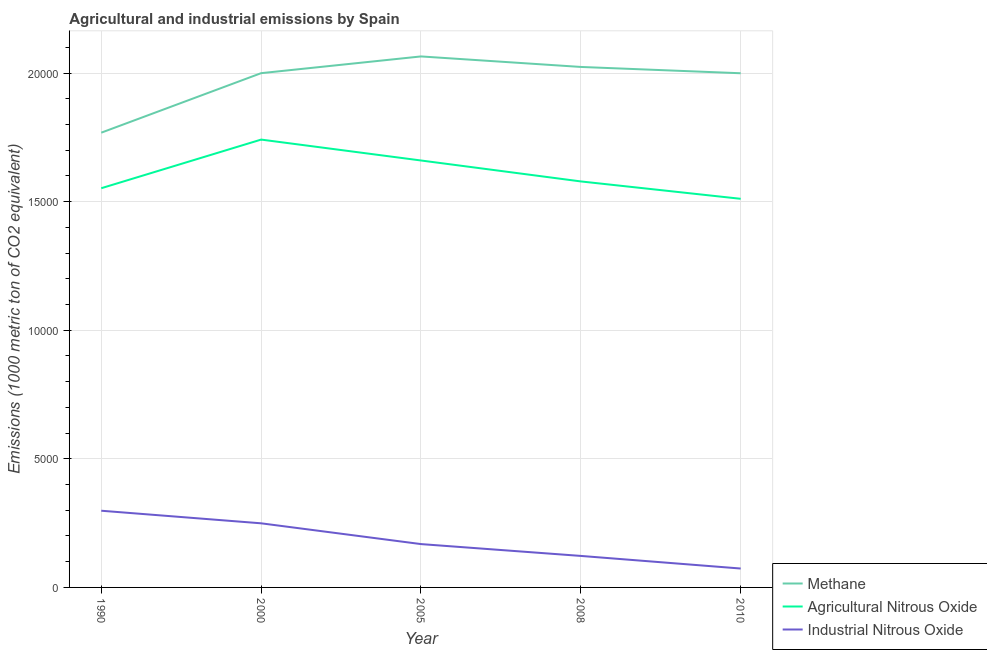How many different coloured lines are there?
Offer a terse response. 3. Is the number of lines equal to the number of legend labels?
Provide a short and direct response. Yes. What is the amount of industrial nitrous oxide emissions in 2010?
Ensure brevity in your answer.  734.8. Across all years, what is the maximum amount of agricultural nitrous oxide emissions?
Provide a short and direct response. 1.74e+04. Across all years, what is the minimum amount of agricultural nitrous oxide emissions?
Your answer should be very brief. 1.51e+04. In which year was the amount of methane emissions maximum?
Make the answer very short. 2005. In which year was the amount of agricultural nitrous oxide emissions minimum?
Provide a short and direct response. 2010. What is the total amount of industrial nitrous oxide emissions in the graph?
Ensure brevity in your answer.  9120.2. What is the difference between the amount of methane emissions in 1990 and that in 2010?
Provide a succinct answer. -2311. What is the difference between the amount of industrial nitrous oxide emissions in 2010 and the amount of methane emissions in 2005?
Keep it short and to the point. -1.99e+04. What is the average amount of methane emissions per year?
Your answer should be very brief. 1.97e+04. In the year 2008, what is the difference between the amount of industrial nitrous oxide emissions and amount of agricultural nitrous oxide emissions?
Offer a very short reply. -1.46e+04. What is the ratio of the amount of industrial nitrous oxide emissions in 1990 to that in 2010?
Offer a terse response. 4.06. Is the amount of industrial nitrous oxide emissions in 1990 less than that in 2005?
Your answer should be very brief. No. Is the difference between the amount of industrial nitrous oxide emissions in 1990 and 2010 greater than the difference between the amount of agricultural nitrous oxide emissions in 1990 and 2010?
Ensure brevity in your answer.  Yes. What is the difference between the highest and the second highest amount of methane emissions?
Offer a terse response. 408.9. What is the difference between the highest and the lowest amount of methane emissions?
Offer a very short reply. 2964.8. In how many years, is the amount of industrial nitrous oxide emissions greater than the average amount of industrial nitrous oxide emissions taken over all years?
Keep it short and to the point. 2. Is the sum of the amount of industrial nitrous oxide emissions in 2005 and 2008 greater than the maximum amount of agricultural nitrous oxide emissions across all years?
Provide a succinct answer. No. Does the amount of methane emissions monotonically increase over the years?
Keep it short and to the point. No. Is the amount of agricultural nitrous oxide emissions strictly greater than the amount of industrial nitrous oxide emissions over the years?
Keep it short and to the point. Yes. Is the amount of methane emissions strictly less than the amount of agricultural nitrous oxide emissions over the years?
Your answer should be compact. No. How many years are there in the graph?
Offer a very short reply. 5. Are the values on the major ticks of Y-axis written in scientific E-notation?
Give a very brief answer. No. Does the graph contain grids?
Provide a short and direct response. Yes. Where does the legend appear in the graph?
Ensure brevity in your answer.  Bottom right. How many legend labels are there?
Ensure brevity in your answer.  3. How are the legend labels stacked?
Your answer should be compact. Vertical. What is the title of the graph?
Keep it short and to the point. Agricultural and industrial emissions by Spain. What is the label or title of the Y-axis?
Your answer should be very brief. Emissions (1000 metric ton of CO2 equivalent). What is the Emissions (1000 metric ton of CO2 equivalent) of Methane in 1990?
Provide a short and direct response. 1.77e+04. What is the Emissions (1000 metric ton of CO2 equivalent) of Agricultural Nitrous Oxide in 1990?
Your answer should be compact. 1.55e+04. What is the Emissions (1000 metric ton of CO2 equivalent) in Industrial Nitrous Oxide in 1990?
Make the answer very short. 2982.4. What is the Emissions (1000 metric ton of CO2 equivalent) of Methane in 2000?
Give a very brief answer. 2.00e+04. What is the Emissions (1000 metric ton of CO2 equivalent) of Agricultural Nitrous Oxide in 2000?
Your answer should be compact. 1.74e+04. What is the Emissions (1000 metric ton of CO2 equivalent) of Industrial Nitrous Oxide in 2000?
Provide a short and direct response. 2493. What is the Emissions (1000 metric ton of CO2 equivalent) of Methane in 2005?
Give a very brief answer. 2.06e+04. What is the Emissions (1000 metric ton of CO2 equivalent) of Agricultural Nitrous Oxide in 2005?
Ensure brevity in your answer.  1.66e+04. What is the Emissions (1000 metric ton of CO2 equivalent) of Industrial Nitrous Oxide in 2005?
Your response must be concise. 1685.1. What is the Emissions (1000 metric ton of CO2 equivalent) of Methane in 2008?
Your response must be concise. 2.02e+04. What is the Emissions (1000 metric ton of CO2 equivalent) in Agricultural Nitrous Oxide in 2008?
Offer a terse response. 1.58e+04. What is the Emissions (1000 metric ton of CO2 equivalent) in Industrial Nitrous Oxide in 2008?
Your response must be concise. 1224.9. What is the Emissions (1000 metric ton of CO2 equivalent) in Methane in 2010?
Offer a terse response. 2.00e+04. What is the Emissions (1000 metric ton of CO2 equivalent) in Agricultural Nitrous Oxide in 2010?
Offer a terse response. 1.51e+04. What is the Emissions (1000 metric ton of CO2 equivalent) in Industrial Nitrous Oxide in 2010?
Your response must be concise. 734.8. Across all years, what is the maximum Emissions (1000 metric ton of CO2 equivalent) in Methane?
Provide a succinct answer. 2.06e+04. Across all years, what is the maximum Emissions (1000 metric ton of CO2 equivalent) of Agricultural Nitrous Oxide?
Offer a very short reply. 1.74e+04. Across all years, what is the maximum Emissions (1000 metric ton of CO2 equivalent) of Industrial Nitrous Oxide?
Your answer should be compact. 2982.4. Across all years, what is the minimum Emissions (1000 metric ton of CO2 equivalent) in Methane?
Offer a terse response. 1.77e+04. Across all years, what is the minimum Emissions (1000 metric ton of CO2 equivalent) in Agricultural Nitrous Oxide?
Give a very brief answer. 1.51e+04. Across all years, what is the minimum Emissions (1000 metric ton of CO2 equivalent) of Industrial Nitrous Oxide?
Your response must be concise. 734.8. What is the total Emissions (1000 metric ton of CO2 equivalent) of Methane in the graph?
Your answer should be compact. 9.86e+04. What is the total Emissions (1000 metric ton of CO2 equivalent) of Agricultural Nitrous Oxide in the graph?
Keep it short and to the point. 8.04e+04. What is the total Emissions (1000 metric ton of CO2 equivalent) in Industrial Nitrous Oxide in the graph?
Provide a short and direct response. 9120.2. What is the difference between the Emissions (1000 metric ton of CO2 equivalent) of Methane in 1990 and that in 2000?
Ensure brevity in your answer.  -2314.1. What is the difference between the Emissions (1000 metric ton of CO2 equivalent) of Agricultural Nitrous Oxide in 1990 and that in 2000?
Offer a very short reply. -1890.8. What is the difference between the Emissions (1000 metric ton of CO2 equivalent) in Industrial Nitrous Oxide in 1990 and that in 2000?
Make the answer very short. 489.4. What is the difference between the Emissions (1000 metric ton of CO2 equivalent) of Methane in 1990 and that in 2005?
Offer a terse response. -2964.8. What is the difference between the Emissions (1000 metric ton of CO2 equivalent) of Agricultural Nitrous Oxide in 1990 and that in 2005?
Offer a very short reply. -1078.3. What is the difference between the Emissions (1000 metric ton of CO2 equivalent) in Industrial Nitrous Oxide in 1990 and that in 2005?
Offer a terse response. 1297.3. What is the difference between the Emissions (1000 metric ton of CO2 equivalent) in Methane in 1990 and that in 2008?
Provide a short and direct response. -2555.9. What is the difference between the Emissions (1000 metric ton of CO2 equivalent) of Agricultural Nitrous Oxide in 1990 and that in 2008?
Provide a short and direct response. -264.1. What is the difference between the Emissions (1000 metric ton of CO2 equivalent) of Industrial Nitrous Oxide in 1990 and that in 2008?
Offer a terse response. 1757.5. What is the difference between the Emissions (1000 metric ton of CO2 equivalent) of Methane in 1990 and that in 2010?
Give a very brief answer. -2311. What is the difference between the Emissions (1000 metric ton of CO2 equivalent) in Agricultural Nitrous Oxide in 1990 and that in 2010?
Offer a very short reply. 411.7. What is the difference between the Emissions (1000 metric ton of CO2 equivalent) in Industrial Nitrous Oxide in 1990 and that in 2010?
Your answer should be compact. 2247.6. What is the difference between the Emissions (1000 metric ton of CO2 equivalent) in Methane in 2000 and that in 2005?
Provide a succinct answer. -650.7. What is the difference between the Emissions (1000 metric ton of CO2 equivalent) of Agricultural Nitrous Oxide in 2000 and that in 2005?
Provide a short and direct response. 812.5. What is the difference between the Emissions (1000 metric ton of CO2 equivalent) of Industrial Nitrous Oxide in 2000 and that in 2005?
Offer a terse response. 807.9. What is the difference between the Emissions (1000 metric ton of CO2 equivalent) in Methane in 2000 and that in 2008?
Provide a short and direct response. -241.8. What is the difference between the Emissions (1000 metric ton of CO2 equivalent) in Agricultural Nitrous Oxide in 2000 and that in 2008?
Offer a terse response. 1626.7. What is the difference between the Emissions (1000 metric ton of CO2 equivalent) of Industrial Nitrous Oxide in 2000 and that in 2008?
Provide a short and direct response. 1268.1. What is the difference between the Emissions (1000 metric ton of CO2 equivalent) in Methane in 2000 and that in 2010?
Provide a succinct answer. 3.1. What is the difference between the Emissions (1000 metric ton of CO2 equivalent) of Agricultural Nitrous Oxide in 2000 and that in 2010?
Make the answer very short. 2302.5. What is the difference between the Emissions (1000 metric ton of CO2 equivalent) in Industrial Nitrous Oxide in 2000 and that in 2010?
Keep it short and to the point. 1758.2. What is the difference between the Emissions (1000 metric ton of CO2 equivalent) in Methane in 2005 and that in 2008?
Provide a succinct answer. 408.9. What is the difference between the Emissions (1000 metric ton of CO2 equivalent) of Agricultural Nitrous Oxide in 2005 and that in 2008?
Give a very brief answer. 814.2. What is the difference between the Emissions (1000 metric ton of CO2 equivalent) of Industrial Nitrous Oxide in 2005 and that in 2008?
Your answer should be very brief. 460.2. What is the difference between the Emissions (1000 metric ton of CO2 equivalent) in Methane in 2005 and that in 2010?
Offer a terse response. 653.8. What is the difference between the Emissions (1000 metric ton of CO2 equivalent) of Agricultural Nitrous Oxide in 2005 and that in 2010?
Make the answer very short. 1490. What is the difference between the Emissions (1000 metric ton of CO2 equivalent) of Industrial Nitrous Oxide in 2005 and that in 2010?
Your answer should be very brief. 950.3. What is the difference between the Emissions (1000 metric ton of CO2 equivalent) of Methane in 2008 and that in 2010?
Provide a succinct answer. 244.9. What is the difference between the Emissions (1000 metric ton of CO2 equivalent) in Agricultural Nitrous Oxide in 2008 and that in 2010?
Provide a succinct answer. 675.8. What is the difference between the Emissions (1000 metric ton of CO2 equivalent) of Industrial Nitrous Oxide in 2008 and that in 2010?
Offer a very short reply. 490.1. What is the difference between the Emissions (1000 metric ton of CO2 equivalent) in Methane in 1990 and the Emissions (1000 metric ton of CO2 equivalent) in Agricultural Nitrous Oxide in 2000?
Offer a terse response. 268.8. What is the difference between the Emissions (1000 metric ton of CO2 equivalent) in Methane in 1990 and the Emissions (1000 metric ton of CO2 equivalent) in Industrial Nitrous Oxide in 2000?
Make the answer very short. 1.52e+04. What is the difference between the Emissions (1000 metric ton of CO2 equivalent) of Agricultural Nitrous Oxide in 1990 and the Emissions (1000 metric ton of CO2 equivalent) of Industrial Nitrous Oxide in 2000?
Your answer should be compact. 1.30e+04. What is the difference between the Emissions (1000 metric ton of CO2 equivalent) in Methane in 1990 and the Emissions (1000 metric ton of CO2 equivalent) in Agricultural Nitrous Oxide in 2005?
Provide a succinct answer. 1081.3. What is the difference between the Emissions (1000 metric ton of CO2 equivalent) of Methane in 1990 and the Emissions (1000 metric ton of CO2 equivalent) of Industrial Nitrous Oxide in 2005?
Provide a succinct answer. 1.60e+04. What is the difference between the Emissions (1000 metric ton of CO2 equivalent) in Agricultural Nitrous Oxide in 1990 and the Emissions (1000 metric ton of CO2 equivalent) in Industrial Nitrous Oxide in 2005?
Make the answer very short. 1.38e+04. What is the difference between the Emissions (1000 metric ton of CO2 equivalent) of Methane in 1990 and the Emissions (1000 metric ton of CO2 equivalent) of Agricultural Nitrous Oxide in 2008?
Offer a terse response. 1895.5. What is the difference between the Emissions (1000 metric ton of CO2 equivalent) of Methane in 1990 and the Emissions (1000 metric ton of CO2 equivalent) of Industrial Nitrous Oxide in 2008?
Your answer should be very brief. 1.65e+04. What is the difference between the Emissions (1000 metric ton of CO2 equivalent) in Agricultural Nitrous Oxide in 1990 and the Emissions (1000 metric ton of CO2 equivalent) in Industrial Nitrous Oxide in 2008?
Keep it short and to the point. 1.43e+04. What is the difference between the Emissions (1000 metric ton of CO2 equivalent) in Methane in 1990 and the Emissions (1000 metric ton of CO2 equivalent) in Agricultural Nitrous Oxide in 2010?
Your response must be concise. 2571.3. What is the difference between the Emissions (1000 metric ton of CO2 equivalent) in Methane in 1990 and the Emissions (1000 metric ton of CO2 equivalent) in Industrial Nitrous Oxide in 2010?
Make the answer very short. 1.69e+04. What is the difference between the Emissions (1000 metric ton of CO2 equivalent) in Agricultural Nitrous Oxide in 1990 and the Emissions (1000 metric ton of CO2 equivalent) in Industrial Nitrous Oxide in 2010?
Give a very brief answer. 1.48e+04. What is the difference between the Emissions (1000 metric ton of CO2 equivalent) in Methane in 2000 and the Emissions (1000 metric ton of CO2 equivalent) in Agricultural Nitrous Oxide in 2005?
Make the answer very short. 3395.4. What is the difference between the Emissions (1000 metric ton of CO2 equivalent) in Methane in 2000 and the Emissions (1000 metric ton of CO2 equivalent) in Industrial Nitrous Oxide in 2005?
Provide a short and direct response. 1.83e+04. What is the difference between the Emissions (1000 metric ton of CO2 equivalent) in Agricultural Nitrous Oxide in 2000 and the Emissions (1000 metric ton of CO2 equivalent) in Industrial Nitrous Oxide in 2005?
Your answer should be very brief. 1.57e+04. What is the difference between the Emissions (1000 metric ton of CO2 equivalent) of Methane in 2000 and the Emissions (1000 metric ton of CO2 equivalent) of Agricultural Nitrous Oxide in 2008?
Give a very brief answer. 4209.6. What is the difference between the Emissions (1000 metric ton of CO2 equivalent) of Methane in 2000 and the Emissions (1000 metric ton of CO2 equivalent) of Industrial Nitrous Oxide in 2008?
Your answer should be compact. 1.88e+04. What is the difference between the Emissions (1000 metric ton of CO2 equivalent) of Agricultural Nitrous Oxide in 2000 and the Emissions (1000 metric ton of CO2 equivalent) of Industrial Nitrous Oxide in 2008?
Provide a succinct answer. 1.62e+04. What is the difference between the Emissions (1000 metric ton of CO2 equivalent) in Methane in 2000 and the Emissions (1000 metric ton of CO2 equivalent) in Agricultural Nitrous Oxide in 2010?
Offer a terse response. 4885.4. What is the difference between the Emissions (1000 metric ton of CO2 equivalent) in Methane in 2000 and the Emissions (1000 metric ton of CO2 equivalent) in Industrial Nitrous Oxide in 2010?
Your response must be concise. 1.93e+04. What is the difference between the Emissions (1000 metric ton of CO2 equivalent) in Agricultural Nitrous Oxide in 2000 and the Emissions (1000 metric ton of CO2 equivalent) in Industrial Nitrous Oxide in 2010?
Keep it short and to the point. 1.67e+04. What is the difference between the Emissions (1000 metric ton of CO2 equivalent) in Methane in 2005 and the Emissions (1000 metric ton of CO2 equivalent) in Agricultural Nitrous Oxide in 2008?
Offer a very short reply. 4860.3. What is the difference between the Emissions (1000 metric ton of CO2 equivalent) in Methane in 2005 and the Emissions (1000 metric ton of CO2 equivalent) in Industrial Nitrous Oxide in 2008?
Provide a short and direct response. 1.94e+04. What is the difference between the Emissions (1000 metric ton of CO2 equivalent) of Agricultural Nitrous Oxide in 2005 and the Emissions (1000 metric ton of CO2 equivalent) of Industrial Nitrous Oxide in 2008?
Give a very brief answer. 1.54e+04. What is the difference between the Emissions (1000 metric ton of CO2 equivalent) in Methane in 2005 and the Emissions (1000 metric ton of CO2 equivalent) in Agricultural Nitrous Oxide in 2010?
Give a very brief answer. 5536.1. What is the difference between the Emissions (1000 metric ton of CO2 equivalent) of Methane in 2005 and the Emissions (1000 metric ton of CO2 equivalent) of Industrial Nitrous Oxide in 2010?
Give a very brief answer. 1.99e+04. What is the difference between the Emissions (1000 metric ton of CO2 equivalent) in Agricultural Nitrous Oxide in 2005 and the Emissions (1000 metric ton of CO2 equivalent) in Industrial Nitrous Oxide in 2010?
Make the answer very short. 1.59e+04. What is the difference between the Emissions (1000 metric ton of CO2 equivalent) in Methane in 2008 and the Emissions (1000 metric ton of CO2 equivalent) in Agricultural Nitrous Oxide in 2010?
Keep it short and to the point. 5127.2. What is the difference between the Emissions (1000 metric ton of CO2 equivalent) of Methane in 2008 and the Emissions (1000 metric ton of CO2 equivalent) of Industrial Nitrous Oxide in 2010?
Make the answer very short. 1.95e+04. What is the difference between the Emissions (1000 metric ton of CO2 equivalent) of Agricultural Nitrous Oxide in 2008 and the Emissions (1000 metric ton of CO2 equivalent) of Industrial Nitrous Oxide in 2010?
Your answer should be very brief. 1.51e+04. What is the average Emissions (1000 metric ton of CO2 equivalent) in Methane per year?
Ensure brevity in your answer.  1.97e+04. What is the average Emissions (1000 metric ton of CO2 equivalent) of Agricultural Nitrous Oxide per year?
Keep it short and to the point. 1.61e+04. What is the average Emissions (1000 metric ton of CO2 equivalent) of Industrial Nitrous Oxide per year?
Your answer should be compact. 1824.04. In the year 1990, what is the difference between the Emissions (1000 metric ton of CO2 equivalent) of Methane and Emissions (1000 metric ton of CO2 equivalent) of Agricultural Nitrous Oxide?
Provide a short and direct response. 2159.6. In the year 1990, what is the difference between the Emissions (1000 metric ton of CO2 equivalent) of Methane and Emissions (1000 metric ton of CO2 equivalent) of Industrial Nitrous Oxide?
Provide a short and direct response. 1.47e+04. In the year 1990, what is the difference between the Emissions (1000 metric ton of CO2 equivalent) in Agricultural Nitrous Oxide and Emissions (1000 metric ton of CO2 equivalent) in Industrial Nitrous Oxide?
Your answer should be very brief. 1.25e+04. In the year 2000, what is the difference between the Emissions (1000 metric ton of CO2 equivalent) of Methane and Emissions (1000 metric ton of CO2 equivalent) of Agricultural Nitrous Oxide?
Ensure brevity in your answer.  2582.9. In the year 2000, what is the difference between the Emissions (1000 metric ton of CO2 equivalent) in Methane and Emissions (1000 metric ton of CO2 equivalent) in Industrial Nitrous Oxide?
Provide a succinct answer. 1.75e+04. In the year 2000, what is the difference between the Emissions (1000 metric ton of CO2 equivalent) of Agricultural Nitrous Oxide and Emissions (1000 metric ton of CO2 equivalent) of Industrial Nitrous Oxide?
Provide a short and direct response. 1.49e+04. In the year 2005, what is the difference between the Emissions (1000 metric ton of CO2 equivalent) in Methane and Emissions (1000 metric ton of CO2 equivalent) in Agricultural Nitrous Oxide?
Your answer should be very brief. 4046.1. In the year 2005, what is the difference between the Emissions (1000 metric ton of CO2 equivalent) in Methane and Emissions (1000 metric ton of CO2 equivalent) in Industrial Nitrous Oxide?
Offer a terse response. 1.90e+04. In the year 2005, what is the difference between the Emissions (1000 metric ton of CO2 equivalent) of Agricultural Nitrous Oxide and Emissions (1000 metric ton of CO2 equivalent) of Industrial Nitrous Oxide?
Provide a succinct answer. 1.49e+04. In the year 2008, what is the difference between the Emissions (1000 metric ton of CO2 equivalent) in Methane and Emissions (1000 metric ton of CO2 equivalent) in Agricultural Nitrous Oxide?
Your answer should be compact. 4451.4. In the year 2008, what is the difference between the Emissions (1000 metric ton of CO2 equivalent) in Methane and Emissions (1000 metric ton of CO2 equivalent) in Industrial Nitrous Oxide?
Your response must be concise. 1.90e+04. In the year 2008, what is the difference between the Emissions (1000 metric ton of CO2 equivalent) in Agricultural Nitrous Oxide and Emissions (1000 metric ton of CO2 equivalent) in Industrial Nitrous Oxide?
Provide a succinct answer. 1.46e+04. In the year 2010, what is the difference between the Emissions (1000 metric ton of CO2 equivalent) of Methane and Emissions (1000 metric ton of CO2 equivalent) of Agricultural Nitrous Oxide?
Your response must be concise. 4882.3. In the year 2010, what is the difference between the Emissions (1000 metric ton of CO2 equivalent) of Methane and Emissions (1000 metric ton of CO2 equivalent) of Industrial Nitrous Oxide?
Your response must be concise. 1.93e+04. In the year 2010, what is the difference between the Emissions (1000 metric ton of CO2 equivalent) in Agricultural Nitrous Oxide and Emissions (1000 metric ton of CO2 equivalent) in Industrial Nitrous Oxide?
Provide a short and direct response. 1.44e+04. What is the ratio of the Emissions (1000 metric ton of CO2 equivalent) in Methane in 1990 to that in 2000?
Your answer should be very brief. 0.88. What is the ratio of the Emissions (1000 metric ton of CO2 equivalent) of Agricultural Nitrous Oxide in 1990 to that in 2000?
Offer a very short reply. 0.89. What is the ratio of the Emissions (1000 metric ton of CO2 equivalent) in Industrial Nitrous Oxide in 1990 to that in 2000?
Provide a short and direct response. 1.2. What is the ratio of the Emissions (1000 metric ton of CO2 equivalent) in Methane in 1990 to that in 2005?
Your answer should be compact. 0.86. What is the ratio of the Emissions (1000 metric ton of CO2 equivalent) in Agricultural Nitrous Oxide in 1990 to that in 2005?
Your answer should be compact. 0.94. What is the ratio of the Emissions (1000 metric ton of CO2 equivalent) of Industrial Nitrous Oxide in 1990 to that in 2005?
Ensure brevity in your answer.  1.77. What is the ratio of the Emissions (1000 metric ton of CO2 equivalent) of Methane in 1990 to that in 2008?
Make the answer very short. 0.87. What is the ratio of the Emissions (1000 metric ton of CO2 equivalent) of Agricultural Nitrous Oxide in 1990 to that in 2008?
Your answer should be very brief. 0.98. What is the ratio of the Emissions (1000 metric ton of CO2 equivalent) of Industrial Nitrous Oxide in 1990 to that in 2008?
Your answer should be compact. 2.43. What is the ratio of the Emissions (1000 metric ton of CO2 equivalent) of Methane in 1990 to that in 2010?
Offer a terse response. 0.88. What is the ratio of the Emissions (1000 metric ton of CO2 equivalent) in Agricultural Nitrous Oxide in 1990 to that in 2010?
Ensure brevity in your answer.  1.03. What is the ratio of the Emissions (1000 metric ton of CO2 equivalent) of Industrial Nitrous Oxide in 1990 to that in 2010?
Keep it short and to the point. 4.06. What is the ratio of the Emissions (1000 metric ton of CO2 equivalent) in Methane in 2000 to that in 2005?
Your answer should be very brief. 0.97. What is the ratio of the Emissions (1000 metric ton of CO2 equivalent) in Agricultural Nitrous Oxide in 2000 to that in 2005?
Offer a terse response. 1.05. What is the ratio of the Emissions (1000 metric ton of CO2 equivalent) of Industrial Nitrous Oxide in 2000 to that in 2005?
Provide a short and direct response. 1.48. What is the ratio of the Emissions (1000 metric ton of CO2 equivalent) in Agricultural Nitrous Oxide in 2000 to that in 2008?
Make the answer very short. 1.1. What is the ratio of the Emissions (1000 metric ton of CO2 equivalent) of Industrial Nitrous Oxide in 2000 to that in 2008?
Ensure brevity in your answer.  2.04. What is the ratio of the Emissions (1000 metric ton of CO2 equivalent) in Agricultural Nitrous Oxide in 2000 to that in 2010?
Provide a short and direct response. 1.15. What is the ratio of the Emissions (1000 metric ton of CO2 equivalent) of Industrial Nitrous Oxide in 2000 to that in 2010?
Offer a terse response. 3.39. What is the ratio of the Emissions (1000 metric ton of CO2 equivalent) in Methane in 2005 to that in 2008?
Ensure brevity in your answer.  1.02. What is the ratio of the Emissions (1000 metric ton of CO2 equivalent) of Agricultural Nitrous Oxide in 2005 to that in 2008?
Your answer should be very brief. 1.05. What is the ratio of the Emissions (1000 metric ton of CO2 equivalent) of Industrial Nitrous Oxide in 2005 to that in 2008?
Keep it short and to the point. 1.38. What is the ratio of the Emissions (1000 metric ton of CO2 equivalent) in Methane in 2005 to that in 2010?
Offer a very short reply. 1.03. What is the ratio of the Emissions (1000 metric ton of CO2 equivalent) in Agricultural Nitrous Oxide in 2005 to that in 2010?
Your answer should be compact. 1.1. What is the ratio of the Emissions (1000 metric ton of CO2 equivalent) in Industrial Nitrous Oxide in 2005 to that in 2010?
Your response must be concise. 2.29. What is the ratio of the Emissions (1000 metric ton of CO2 equivalent) of Methane in 2008 to that in 2010?
Your answer should be compact. 1.01. What is the ratio of the Emissions (1000 metric ton of CO2 equivalent) of Agricultural Nitrous Oxide in 2008 to that in 2010?
Give a very brief answer. 1.04. What is the ratio of the Emissions (1000 metric ton of CO2 equivalent) in Industrial Nitrous Oxide in 2008 to that in 2010?
Offer a terse response. 1.67. What is the difference between the highest and the second highest Emissions (1000 metric ton of CO2 equivalent) in Methane?
Ensure brevity in your answer.  408.9. What is the difference between the highest and the second highest Emissions (1000 metric ton of CO2 equivalent) in Agricultural Nitrous Oxide?
Provide a short and direct response. 812.5. What is the difference between the highest and the second highest Emissions (1000 metric ton of CO2 equivalent) in Industrial Nitrous Oxide?
Provide a succinct answer. 489.4. What is the difference between the highest and the lowest Emissions (1000 metric ton of CO2 equivalent) in Methane?
Keep it short and to the point. 2964.8. What is the difference between the highest and the lowest Emissions (1000 metric ton of CO2 equivalent) in Agricultural Nitrous Oxide?
Make the answer very short. 2302.5. What is the difference between the highest and the lowest Emissions (1000 metric ton of CO2 equivalent) in Industrial Nitrous Oxide?
Provide a short and direct response. 2247.6. 